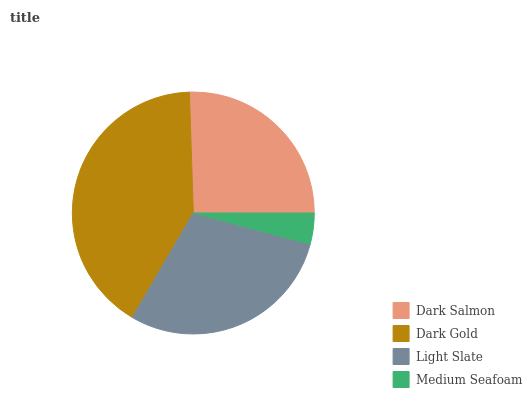Is Medium Seafoam the minimum?
Answer yes or no. Yes. Is Dark Gold the maximum?
Answer yes or no. Yes. Is Light Slate the minimum?
Answer yes or no. No. Is Light Slate the maximum?
Answer yes or no. No. Is Dark Gold greater than Light Slate?
Answer yes or no. Yes. Is Light Slate less than Dark Gold?
Answer yes or no. Yes. Is Light Slate greater than Dark Gold?
Answer yes or no. No. Is Dark Gold less than Light Slate?
Answer yes or no. No. Is Light Slate the high median?
Answer yes or no. Yes. Is Dark Salmon the low median?
Answer yes or no. Yes. Is Dark Gold the high median?
Answer yes or no. No. Is Dark Gold the low median?
Answer yes or no. No. 